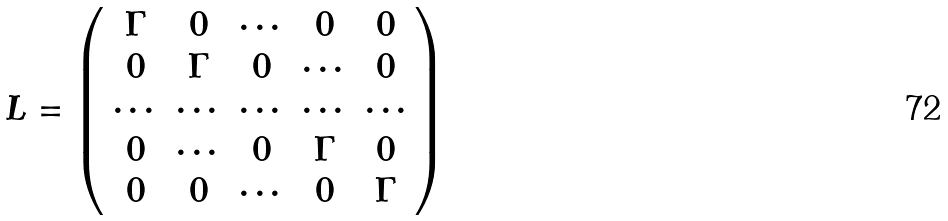Convert formula to latex. <formula><loc_0><loc_0><loc_500><loc_500>L = \left ( \begin{array} { c c c c c } \Gamma & 0 & \cdots & 0 & 0 \\ 0 & \Gamma & 0 & \cdots & 0 \\ \cdots & \cdots & \cdots & \cdots & \cdots \\ 0 & \cdots & 0 & \Gamma & 0 \\ 0 & 0 & \cdots & 0 & \Gamma \end{array} \right )</formula> 